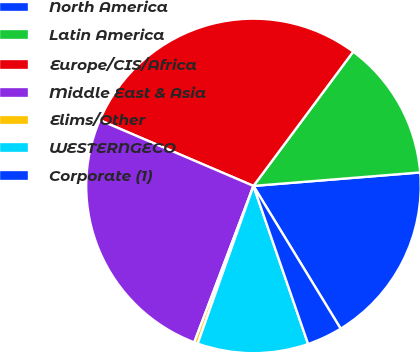Convert chart to OTSL. <chart><loc_0><loc_0><loc_500><loc_500><pie_chart><fcel>North America<fcel>Latin America<fcel>Europe/CIS/Africa<fcel>Middle East & Asia<fcel>Elims/Other<fcel>WESTERNGECO<fcel>Corporate (1)<nl><fcel>17.56%<fcel>13.55%<fcel>28.74%<fcel>25.68%<fcel>0.35%<fcel>10.71%<fcel>3.43%<nl></chart> 